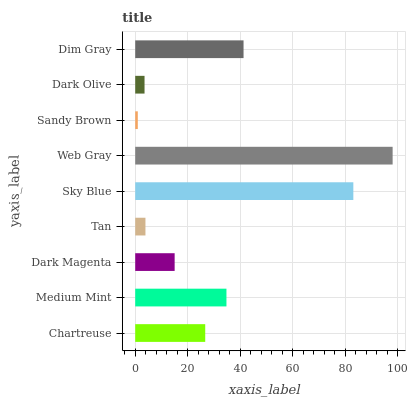Is Sandy Brown the minimum?
Answer yes or no. Yes. Is Web Gray the maximum?
Answer yes or no. Yes. Is Medium Mint the minimum?
Answer yes or no. No. Is Medium Mint the maximum?
Answer yes or no. No. Is Medium Mint greater than Chartreuse?
Answer yes or no. Yes. Is Chartreuse less than Medium Mint?
Answer yes or no. Yes. Is Chartreuse greater than Medium Mint?
Answer yes or no. No. Is Medium Mint less than Chartreuse?
Answer yes or no. No. Is Chartreuse the high median?
Answer yes or no. Yes. Is Chartreuse the low median?
Answer yes or no. Yes. Is Medium Mint the high median?
Answer yes or no. No. Is Dark Olive the low median?
Answer yes or no. No. 